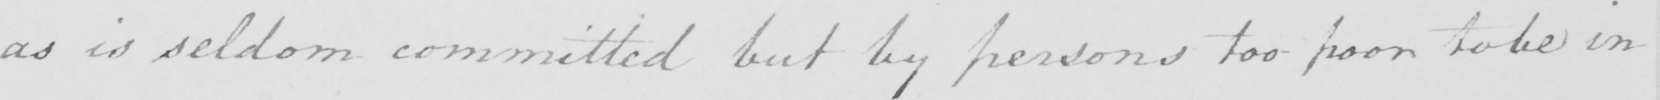Can you read and transcribe this handwriting? as is seldom committed but by persons too poor to be in 